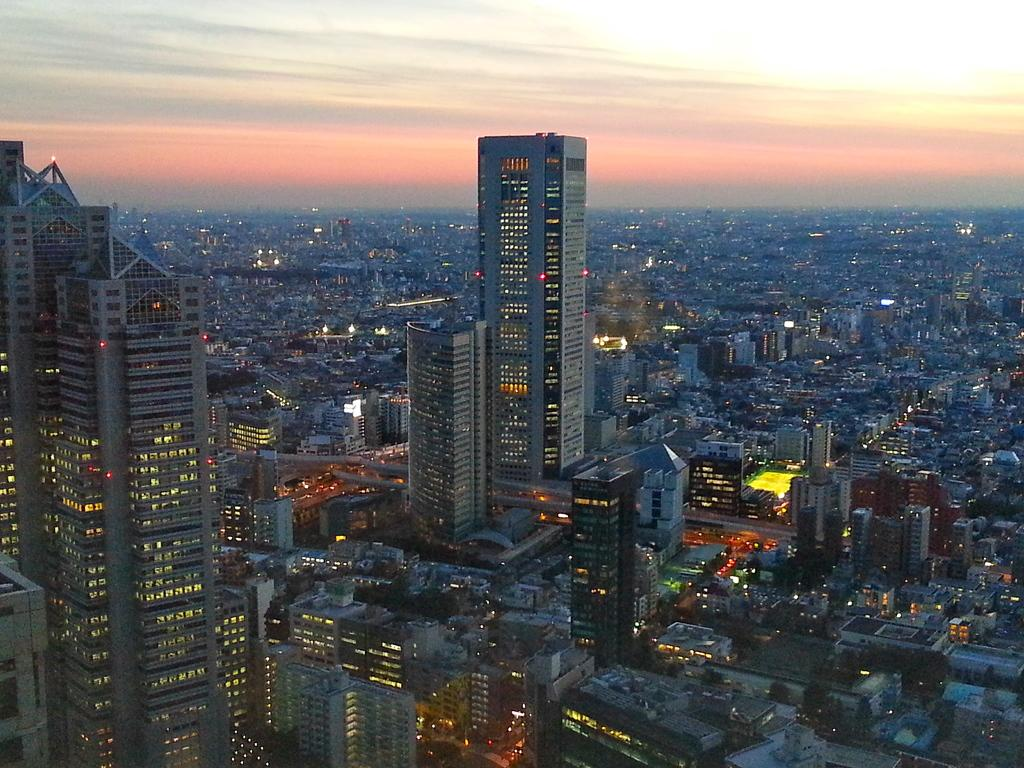What type of structures can be seen in the image? There are many buildings in the image. What other natural elements are present in the image? There are trees in the image. Are there any artificial light sources visible in the image? Yes, there are lights in the image. What type of pathways can be seen in the image? There are roads in the image. What can be seen in the sky in the image? There are clouds in the sky in the image. Can you see any rats running through the park in the image? There is no park present in the image, and therefore no rats can be seen running through it. 